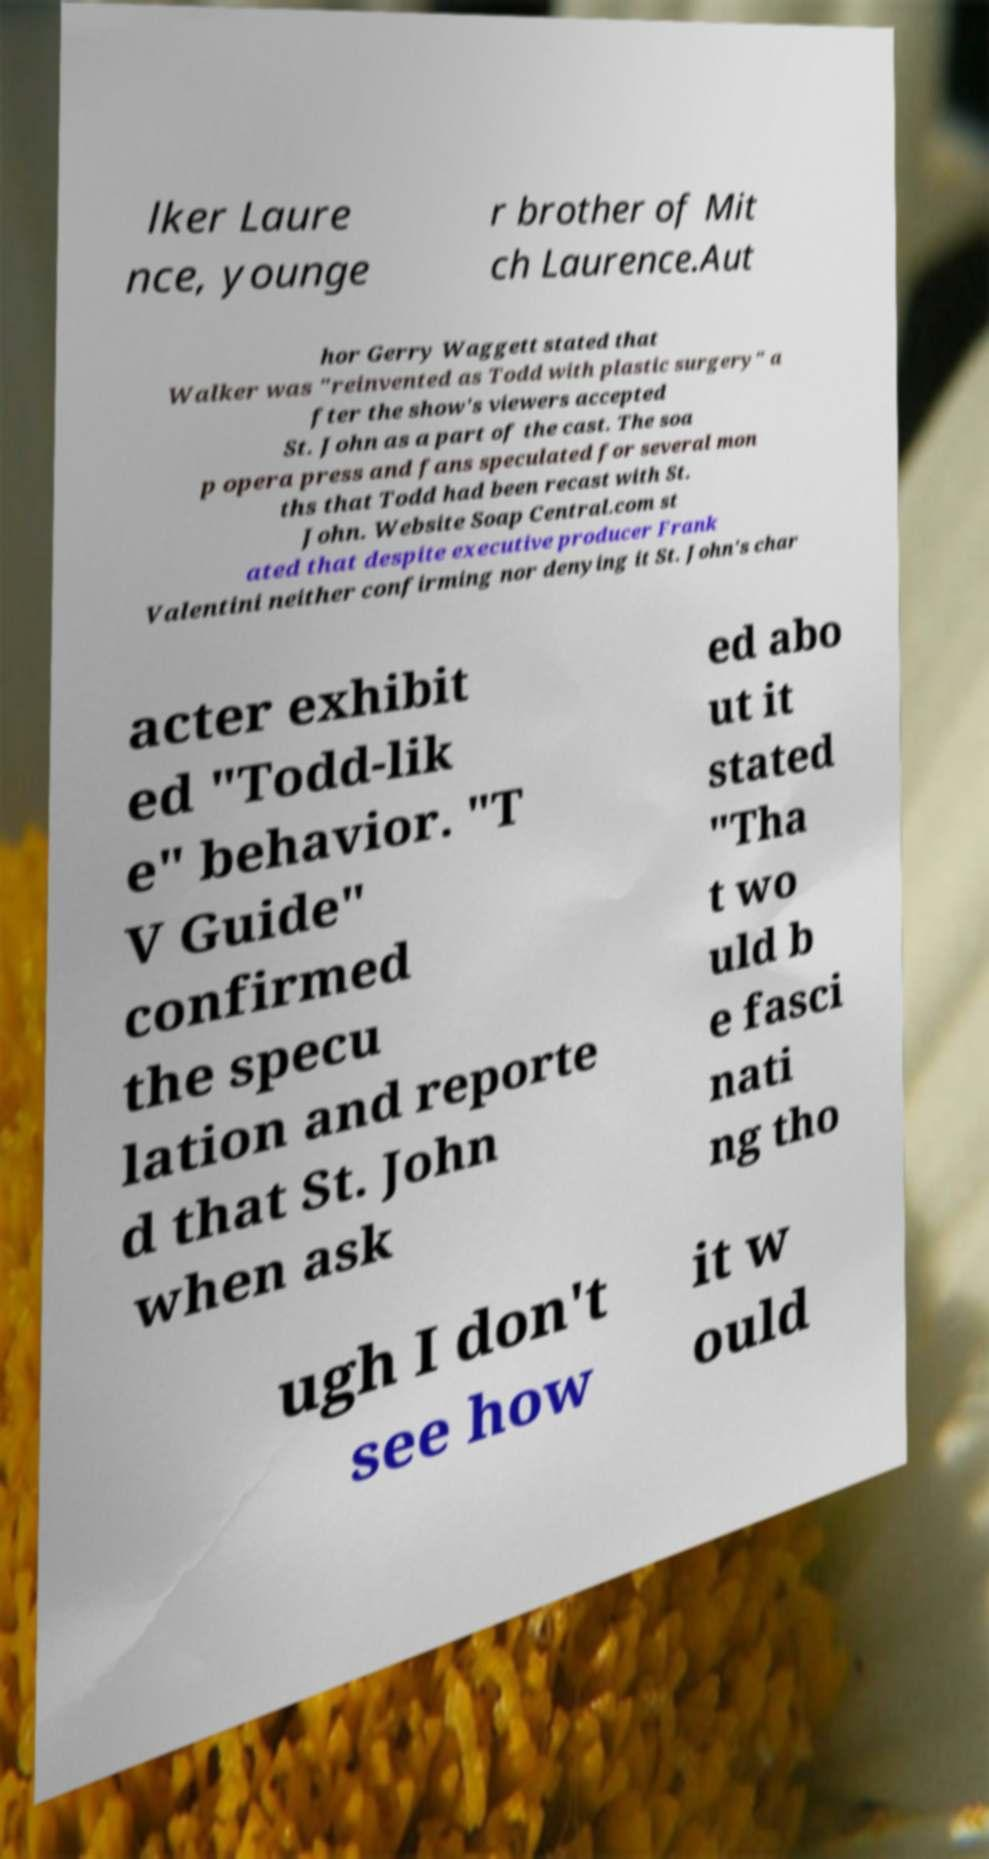Can you read and provide the text displayed in the image?This photo seems to have some interesting text. Can you extract and type it out for me? lker Laure nce, younge r brother of Mit ch Laurence.Aut hor Gerry Waggett stated that Walker was "reinvented as Todd with plastic surgery" a fter the show's viewers accepted St. John as a part of the cast. The soa p opera press and fans speculated for several mon ths that Todd had been recast with St. John. Website Soap Central.com st ated that despite executive producer Frank Valentini neither confirming nor denying it St. John's char acter exhibit ed "Todd-lik e" behavior. "T V Guide" confirmed the specu lation and reporte d that St. John when ask ed abo ut it stated "Tha t wo uld b e fasci nati ng tho ugh I don't see how it w ould 